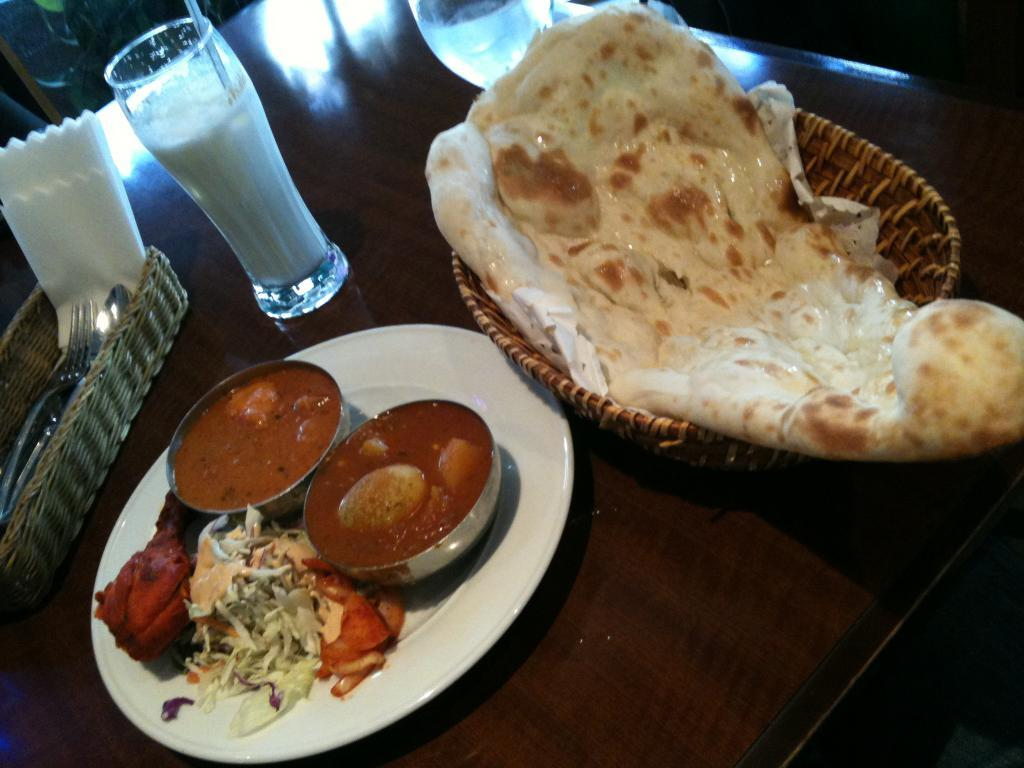What is in the basket that is visible in the image? There is a roti in a basket in the image. What is on the plate in the image? There are food items in a plate in the image. What is on the table in the image? There are glasses on a table in the image. What book is being destroyed by the representative in the image? There is no book or representative present in the image. 